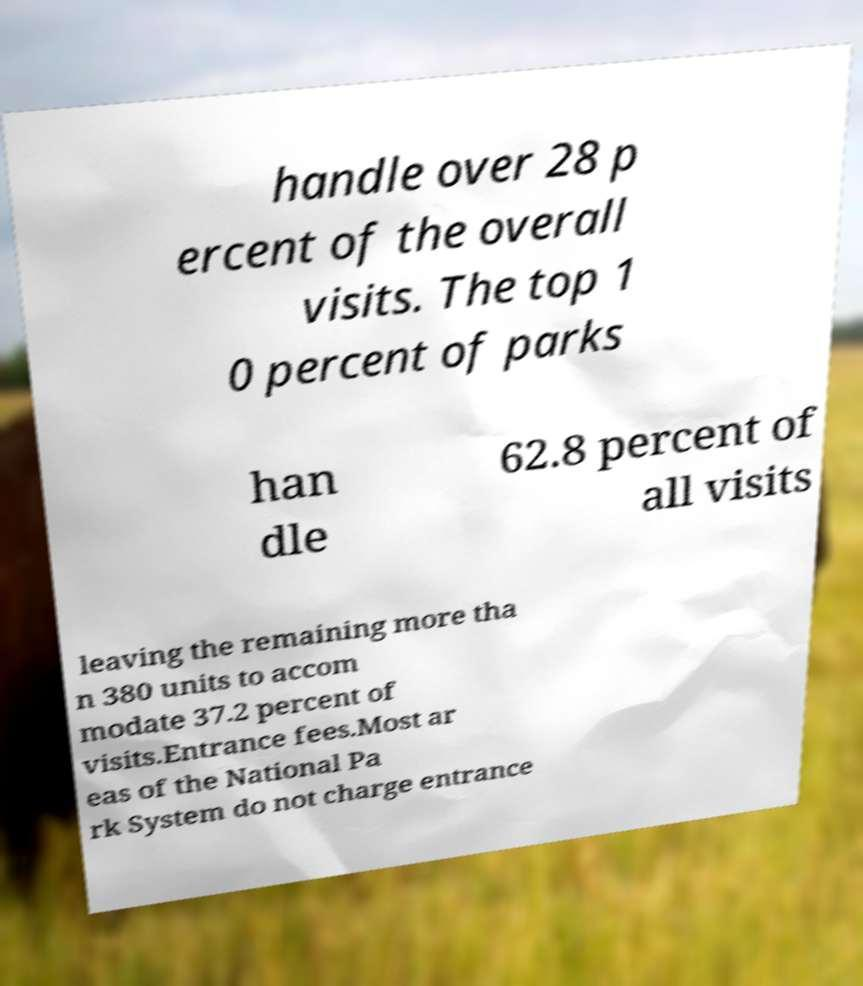What messages or text are displayed in this image? I need them in a readable, typed format. handle over 28 p ercent of the overall visits. The top 1 0 percent of parks han dle 62.8 percent of all visits leaving the remaining more tha n 380 units to accom modate 37.2 percent of visits.Entrance fees.Most ar eas of the National Pa rk System do not charge entrance 